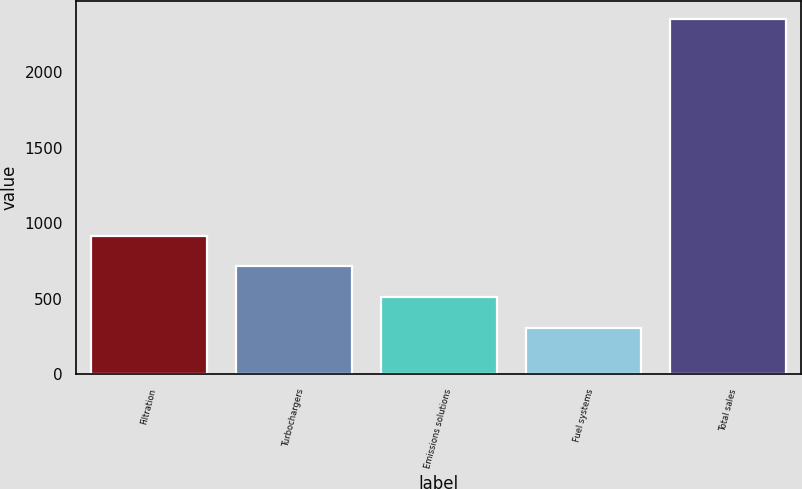<chart> <loc_0><loc_0><loc_500><loc_500><bar_chart><fcel>Filtration<fcel>Turbochargers<fcel>Emissions solutions<fcel>Fuel systems<fcel>Total sales<nl><fcel>920<fcel>715<fcel>510<fcel>305<fcel>2355<nl></chart> 